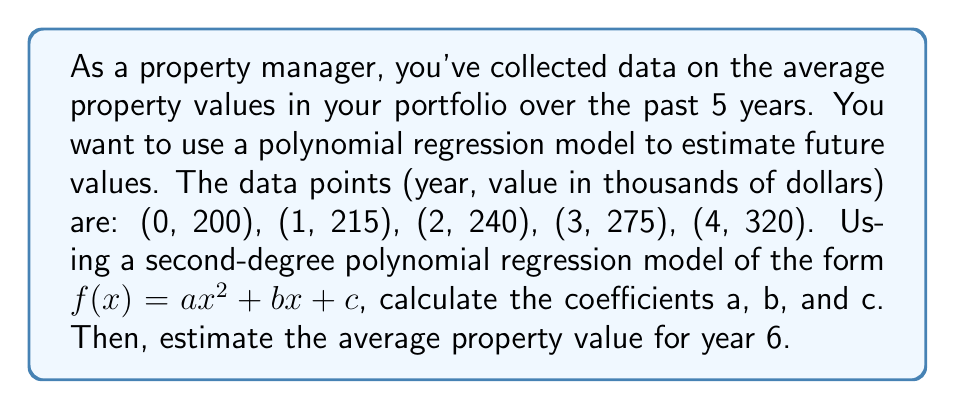Teach me how to tackle this problem. To solve this problem, we'll use the least squares method for polynomial regression:

1. Set up the system of normal equations:
   $$\begin{cases}
   \sum y = an\sum x^2 + b\sum x + nc \\
   \sum xy = a\sum x^3 + b\sum x^2 + c\sum x \\
   \sum x^2y = a\sum x^4 + b\sum x^3 + c\sum x^2
   \end{cases}$$

2. Calculate the sums:
   $\sum x = 0 + 1 + 2 + 3 + 4 = 10$
   $\sum x^2 = 0 + 1 + 4 + 9 + 16 = 30$
   $\sum x^3 = 0 + 1 + 8 + 27 + 64 = 100$
   $\sum x^4 = 0 + 1 + 16 + 81 + 256 = 354$
   $\sum y = 200 + 215 + 240 + 275 + 320 = 1250$
   $\sum xy = 0 + 215 + 480 + 825 + 1280 = 2800$
   $\sum x^2y = 0 + 215 + 960 + 2475 + 5120 = 8770$

3. Substitute into the normal equations:
   $$\begin{cases}
   1250 = 30a + 10b + 5c \\
   2800 = 100a + 30b + 10c \\
   8770 = 354a + 100b + 30c
   \end{cases}$$

4. Solve the system of equations (using matrix methods or elimination):
   $a = 5$, $b = 10$, $c = 200$

5. The polynomial regression model is:
   $f(x) = 5x^2 + 10x + 200$

6. To estimate the average property value for year 6, substitute $x = 6$:
   $f(6) = 5(6^2) + 10(6) + 200 = 5(36) + 60 + 200 = 440$
Answer: The coefficients are $a = 5$, $b = 10$, and $c = 200$. The estimated average property value for year 6 is $440,000. 